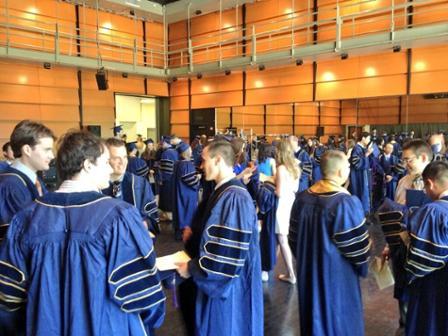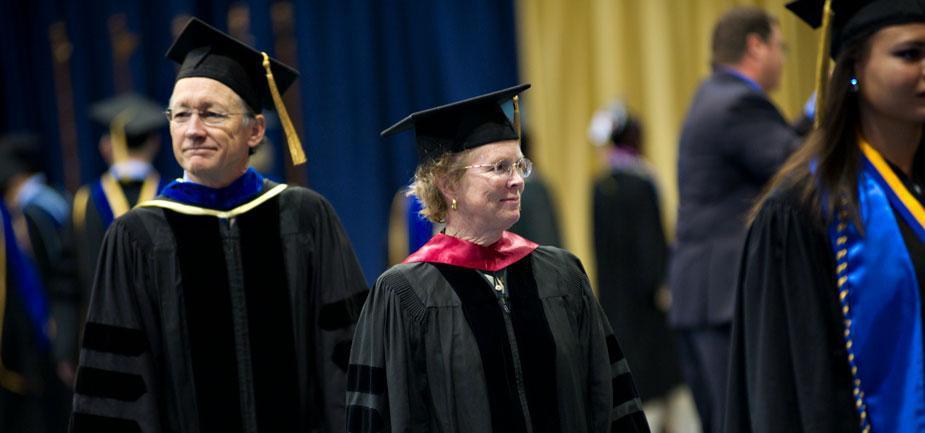The first image is the image on the left, the second image is the image on the right. Examine the images to the left and right. Is the description "Each image contains a long-haired brunette female graduate wearing a sash, robe and hat in the foreground of the picture." accurate? Answer yes or no. No. The first image is the image on the left, the second image is the image on the right. For the images shown, is this caption "In the image to the right, the graduation gown is blue." true? Answer yes or no. No. 